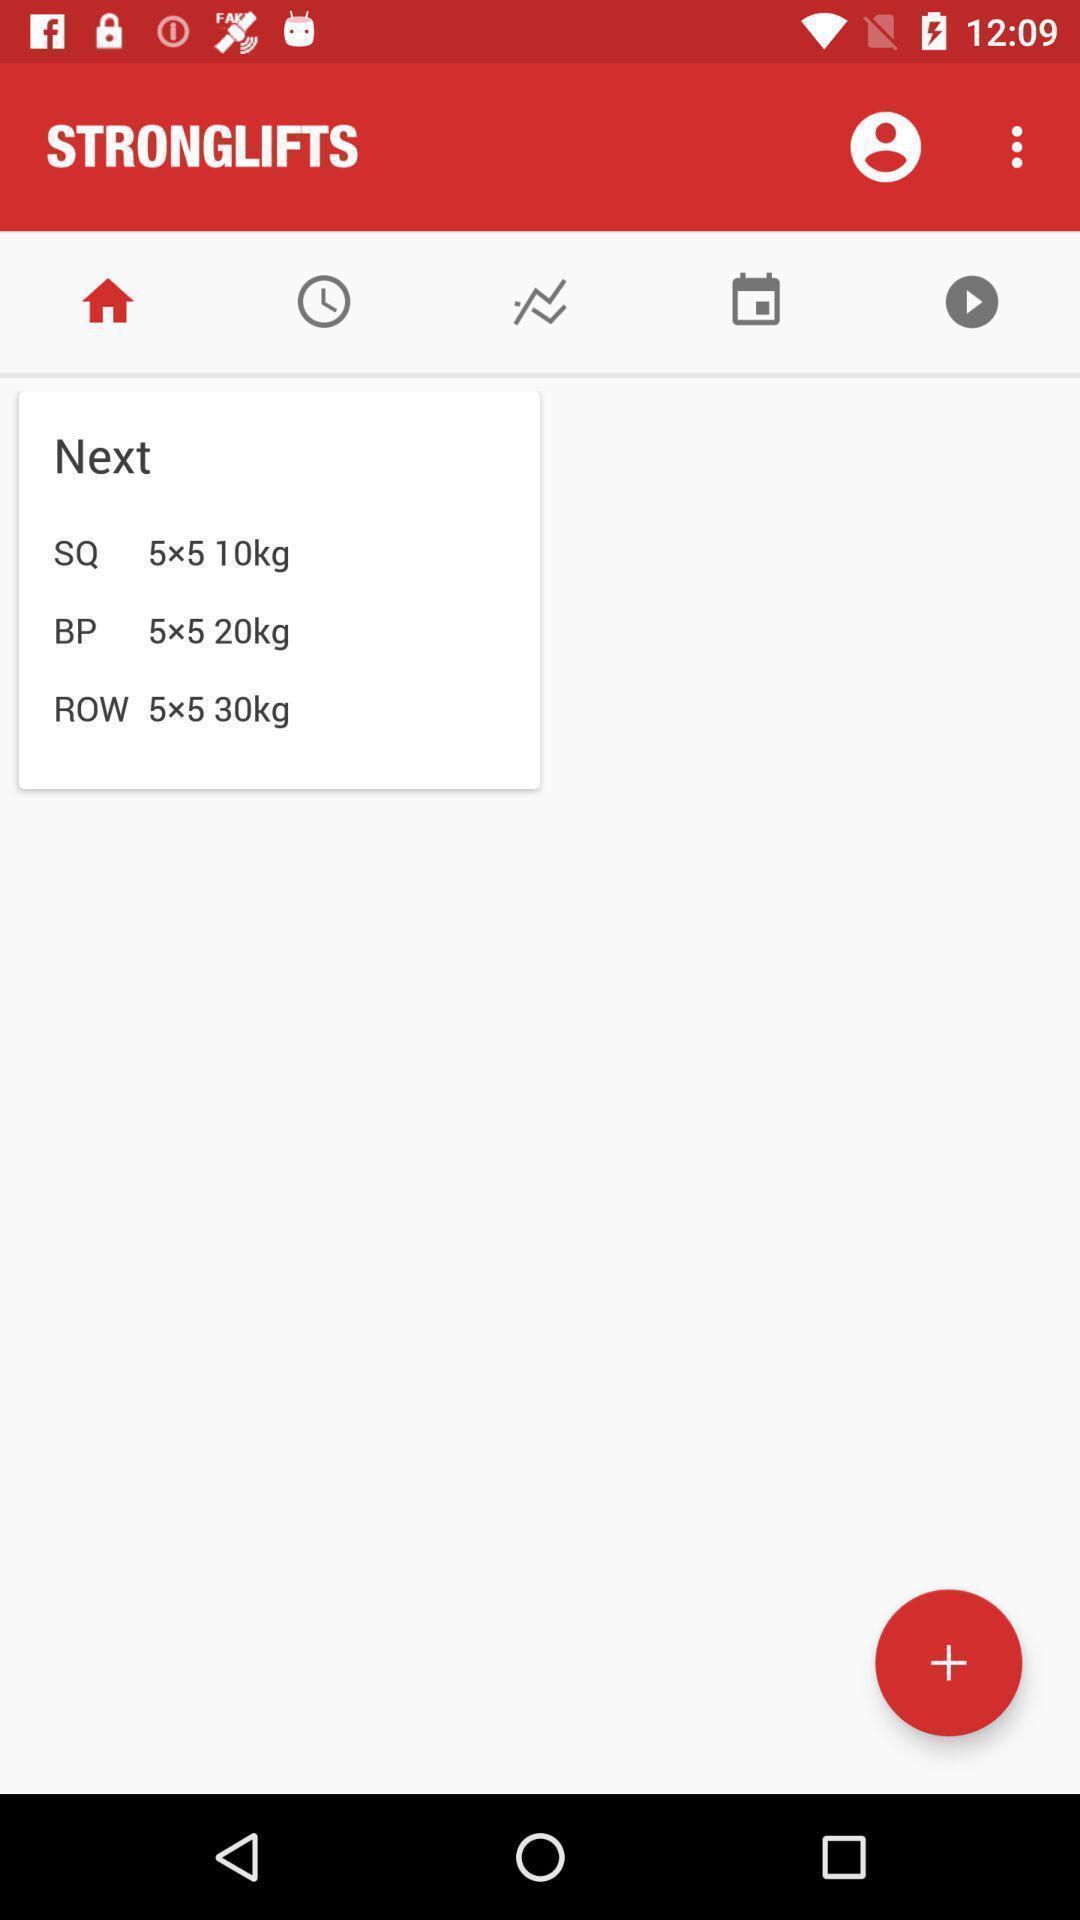Provide a detailed account of this screenshot. Page displaying information about a workout planner application. 